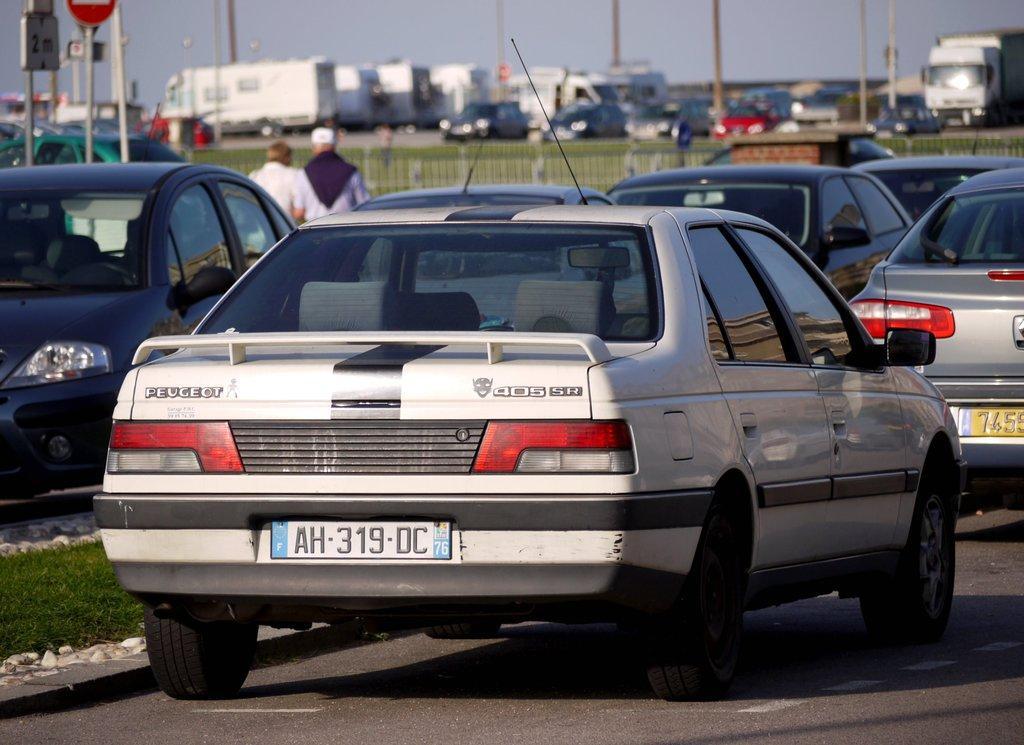Describe this image in one or two sentences. In this picture we can see cars on the road, grass, fence, poles, signboard and two people and in the background we can see vehicles, sky. 